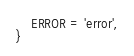<code> <loc_0><loc_0><loc_500><loc_500><_TypeScript_>    ERROR = 'error',
}</code> 